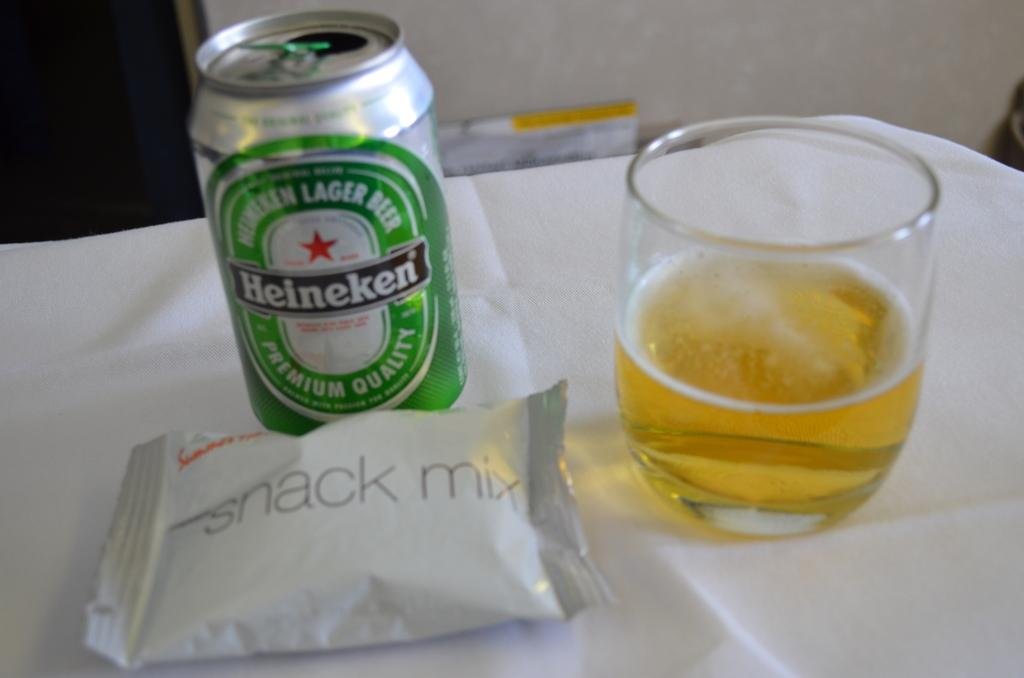<image>
Write a terse but informative summary of the picture. On a white table cloth, a bag of snack mix, Heineken can, and a glass are placed neatly. 